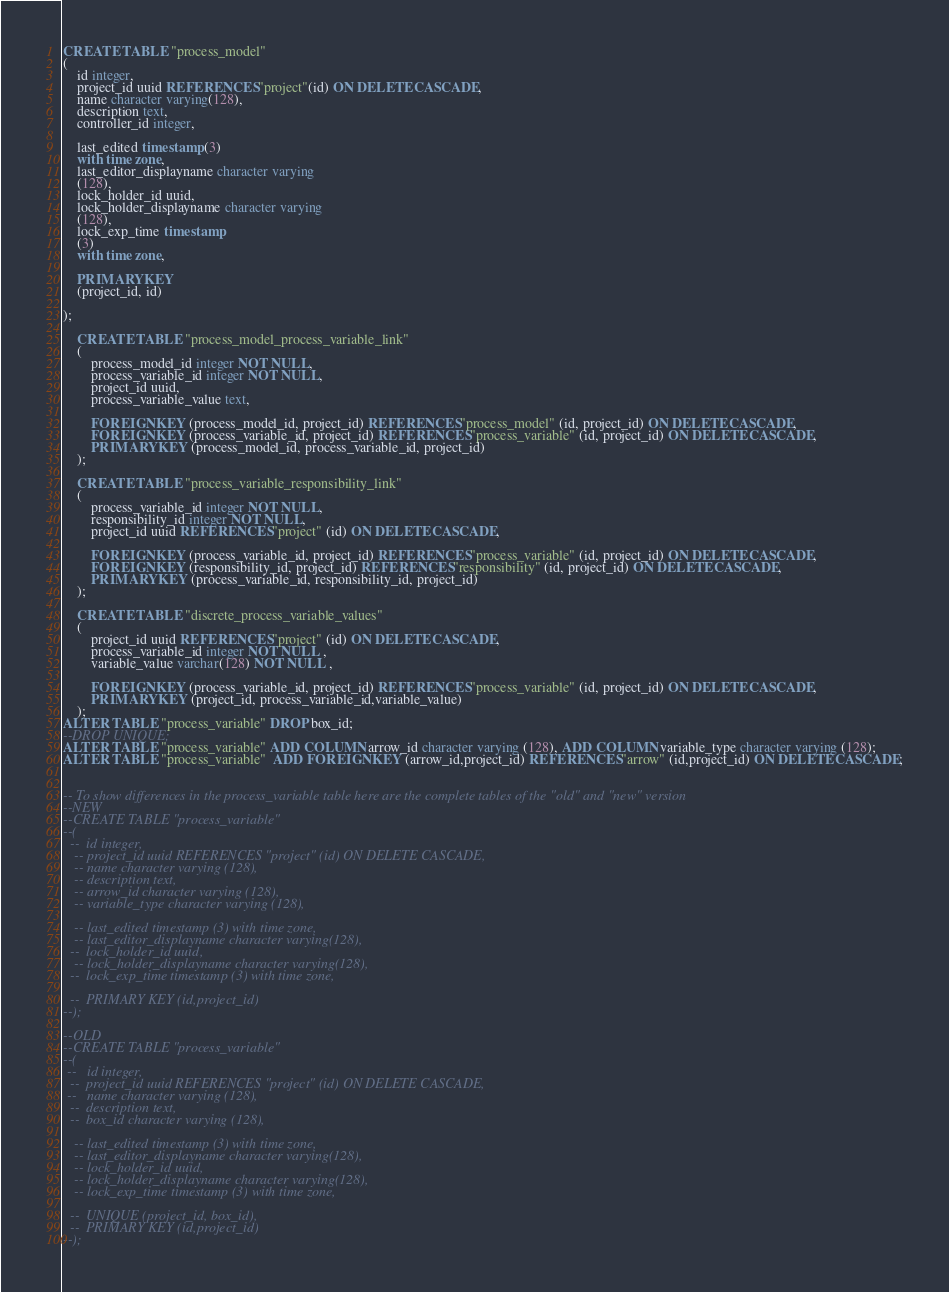Convert code to text. <code><loc_0><loc_0><loc_500><loc_500><_SQL_>CREATE TABLE "process_model"
(
    id integer,
    project_id uuid REFERENCES "project"(id) ON DELETE CASCADE,
    name character varying(128),
    description text,
    controller_id integer,

    last_edited timestamp (3)
    with time zone,
    last_editor_displayname character varying
    (128),
    lock_holder_id uuid,
    lock_holder_displayname character varying
    (128),
    lock_exp_time timestamp
    (3)
    with time zone,

    PRIMARY KEY
    (project_id, id)

);

    CREATE TABLE "process_model_process_variable_link"
    (
        process_model_id integer NOT NULL,
        process_variable_id integer NOT NULL,
        project_id uuid,
        process_variable_value text,

        FOREIGN KEY (process_model_id, project_id) REFERENCES "process_model" (id, project_id) ON DELETE CASCADE,
        FOREIGN KEY (process_variable_id, project_id) REFERENCES "process_variable" (id, project_id) ON DELETE CASCADE,
        PRIMARY KEY (process_model_id, process_variable_id, project_id)
    );

    CREATE TABLE "process_variable_responsibility_link"
    (
        process_variable_id integer NOT NULL,
        responsibility_id integer NOT NULL,
        project_id uuid REFERENCES "project" (id) ON DELETE CASCADE,

        FOREIGN KEY (process_variable_id, project_id) REFERENCES "process_variable" (id, project_id) ON DELETE CASCADE,
        FOREIGN KEY (responsibility_id, project_id) REFERENCES "responsibility" (id, project_id) ON DELETE CASCADE,
        PRIMARY KEY (process_variable_id, responsibility_id, project_id)
    );

    CREATE TABLE "discrete_process_variable_values"
    (
        project_id uuid REFERENCES "project" (id) ON DELETE CASCADE,
        process_variable_id integer NOT NULL ,
        variable_value varchar(128) NOT NULL ,

        FOREIGN KEY (process_variable_id, project_id) REFERENCES "process_variable" (id, project_id) ON DELETE CASCADE,
        PRIMARY KEY (project_id, process_variable_id,variable_value)
    );
ALTER TABLE "process_variable" DROP box_id;
--DROP UNIQUE;
ALTER TABLE "process_variable" ADD COLUMN arrow_id character varying (128), ADD COLUMN variable_type character varying (128);
ALTER TABLE "process_variable"  ADD FOREIGN KEY (arrow_id,project_id) REFERENCES "arrow" (id,project_id) ON DELETE CASCADE;


-- To show differences in the process_variable table here are the complete tables of the "old" and "new" version
--NEW
--CREATE TABLE "process_variable"
--(
  --  id integer,
   -- project_id uuid REFERENCES "project" (id) ON DELETE CASCADE,
   -- name character varying (128),
   -- description text,
   -- arrow_id character varying (128),
   -- variable_type character varying (128),
    
   -- last_edited timestamp (3) with time zone,
   -- last_editor_displayname character varying(128),
  --  lock_holder_id uuid,
   -- lock_holder_displayname character varying(128),
  --  lock_exp_time timestamp (3) with time zone,
    
  --  PRIMARY KEY (id,project_id)
--);

--OLD
--CREATE TABLE "process_variable"
--(
 --   id integer,
  --  project_id uuid REFERENCES "project" (id) ON DELETE CASCADE,
 --   name character varying (128),
  --  description text,
  --  box_id character varying (128),

   -- last_edited timestamp (3) with time zone,
   -- last_editor_displayname character varying(128),
   -- lock_holder_id uuid,
   -- lock_holder_displayname character varying(128),
   -- lock_exp_time timestamp (3) with time zone,

  --  UNIQUE (project_id, box_id),
  --  PRIMARY KEY (id,project_id)
--);
</code> 